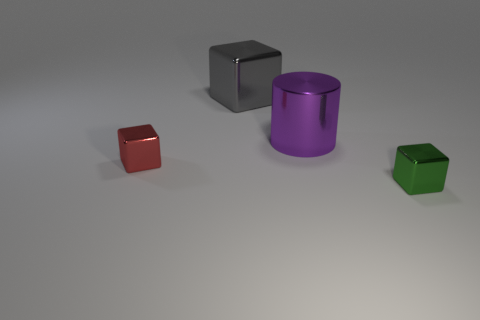How many gray objects are to the left of the shiny cube to the left of the thing that is behind the purple cylinder?
Your answer should be very brief. 0. There is a tiny red metallic thing; does it have the same shape as the shiny thing behind the big purple metal cylinder?
Ensure brevity in your answer.  Yes. There is a block that is left of the small green block and in front of the gray metal object; what color is it?
Your answer should be very brief. Red. What is the small object that is behind the small block on the right side of the tiny block behind the green cube made of?
Ensure brevity in your answer.  Metal. What is the material of the big cylinder?
Your answer should be very brief. Metal. What is the size of the gray metallic thing that is the same shape as the small red object?
Provide a succinct answer. Large. Is the large metallic cylinder the same color as the large cube?
Your answer should be compact. No. What number of other things are the same material as the big gray object?
Provide a short and direct response. 3. Is the number of tiny blocks on the left side of the small green thing the same as the number of big purple shiny cylinders?
Provide a short and direct response. Yes. There is a red shiny block that is in front of the gray object; does it have the same size as the tiny green shiny block?
Your answer should be very brief. Yes. 